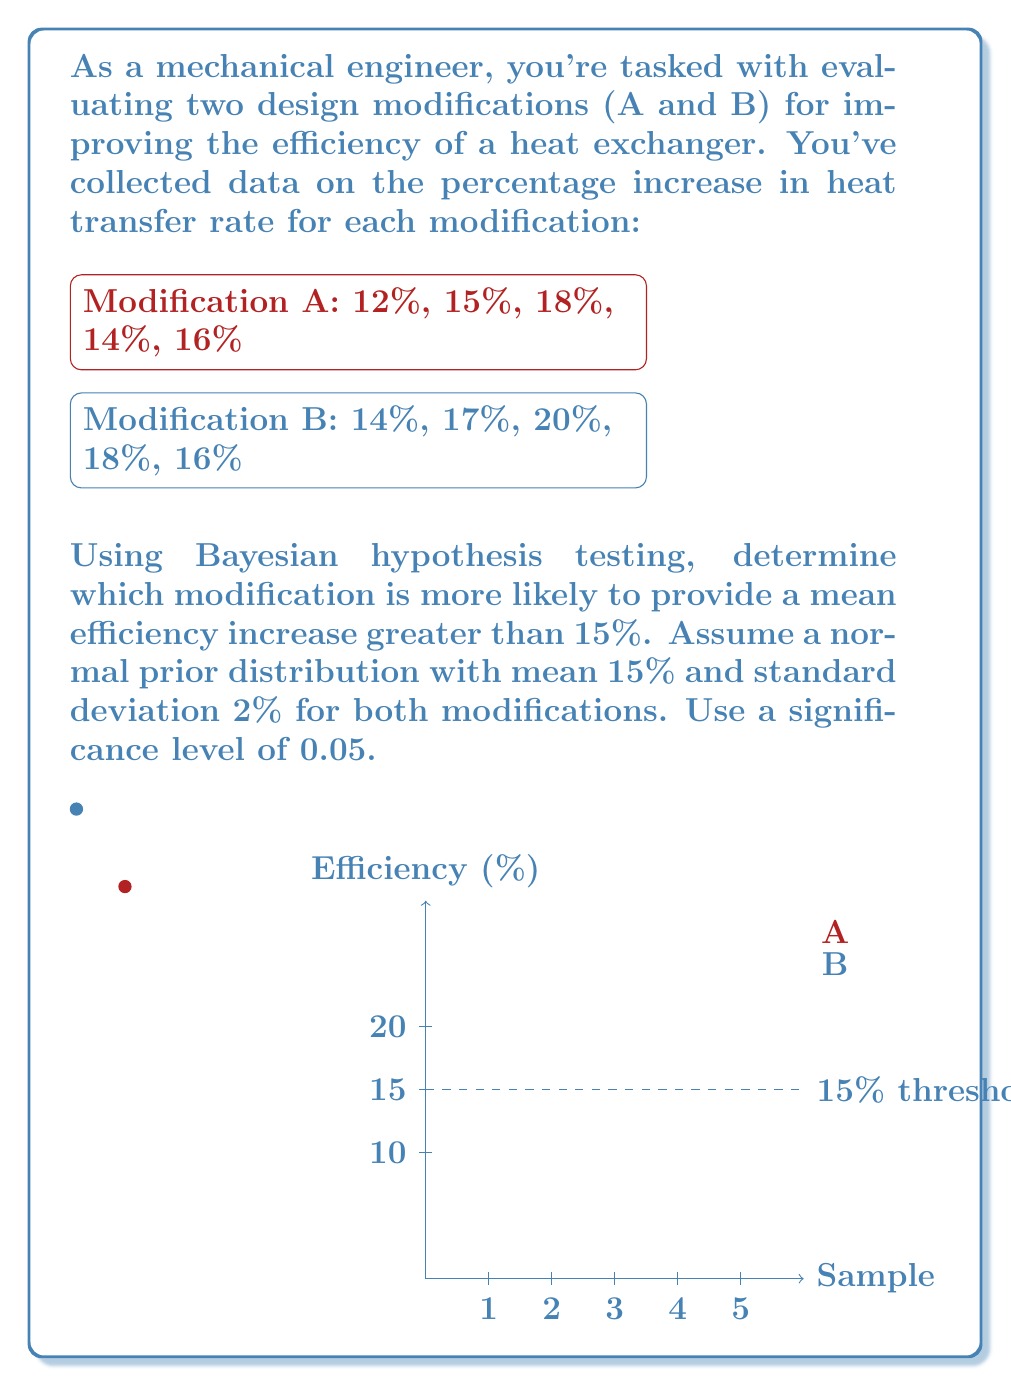Help me with this question. To solve this problem using Bayesian hypothesis testing, we'll follow these steps:

1) Calculate the likelihood of the data given the hypothesis for each modification.
2) Calculate the posterior probability using Bayes' theorem.
3) Compare the posterior probabilities to determine which modification is more likely to exceed 15% efficiency increase.

Step 1: Calculate likelihoods

For both modifications, we'll use the t-distribution to calculate the likelihood, as we don't know the true population variance.

Modification A:
Sample mean: $\bar{x}_A = \frac{12 + 15 + 18 + 14 + 16}{5} = 15$
Sample standard deviation: $s_A = \sqrt{\frac{\sum(x_i - \bar{x})^2}{n-1}} \approx 2.236$

Modification B:
Sample mean: $\bar{x}_B = \frac{14 + 17 + 20 + 18 + 16}{5} = 17$
Sample standard deviation: $s_B = \sqrt{\frac{\sum(x_i - \bar{x})^2}{n-1}} \approx 2.236$

Step 2: Calculate posterior probabilities

Using Bayes' theorem:

$P(H|D) = \frac{P(D|H)P(H)}{P(D)}$

Where H is the hypothesis that the mean efficiency increase is greater than 15%, and D is the observed data.

For Modification A:
$P(H_A|D_A) = \frac{P(D_A|H_A)P(H_A)}{P(D_A)}$

$P(H_A) = P(\mu > 15) = 1 - \Phi(\frac{15-15}{2}) = 0.5$ (using the prior distribution)

$P(D_A|H_A) = 1 - t_4(\frac{15-15}{2.236/\sqrt{5}}) = 0.5$ (using t-distribution with 4 degrees of freedom)

For Modification B:
$P(H_B|D_B) = \frac{P(D_B|H_B)P(H_B)}{P(D_B)}$

$P(H_B) = P(\mu > 15) = 1 - \Phi(\frac{15-15}{2}) = 0.5$ (using the prior distribution)

$P(D_B|H_B) = 1 - t_4(\frac{15-17}{2.236/\sqrt{5}}) \approx 0.9713$ (using t-distribution with 4 degrees of freedom)

Step 3: Compare posterior probabilities

The posterior probability for Modification B (0.9713) is higher than for Modification A (0.5). This indicates that Modification B is more likely to provide a mean efficiency increase greater than 15%.

To confirm statistical significance, we can calculate the Bayes factor:

$BF = \frac{P(D_B|H_B)}{P(D_A|H_A)} = \frac{0.9713}{0.5} \approx 1.9426$

Since the Bayes factor is greater than 1, it supports the hypothesis that Modification B is more effective. However, it's not strong evidence (typically, we look for BF > 3 for strong evidence).
Answer: Modification B is more likely to provide a mean efficiency increase greater than 15%, with a posterior probability of 0.9713 compared to 0.5 for Modification A. 